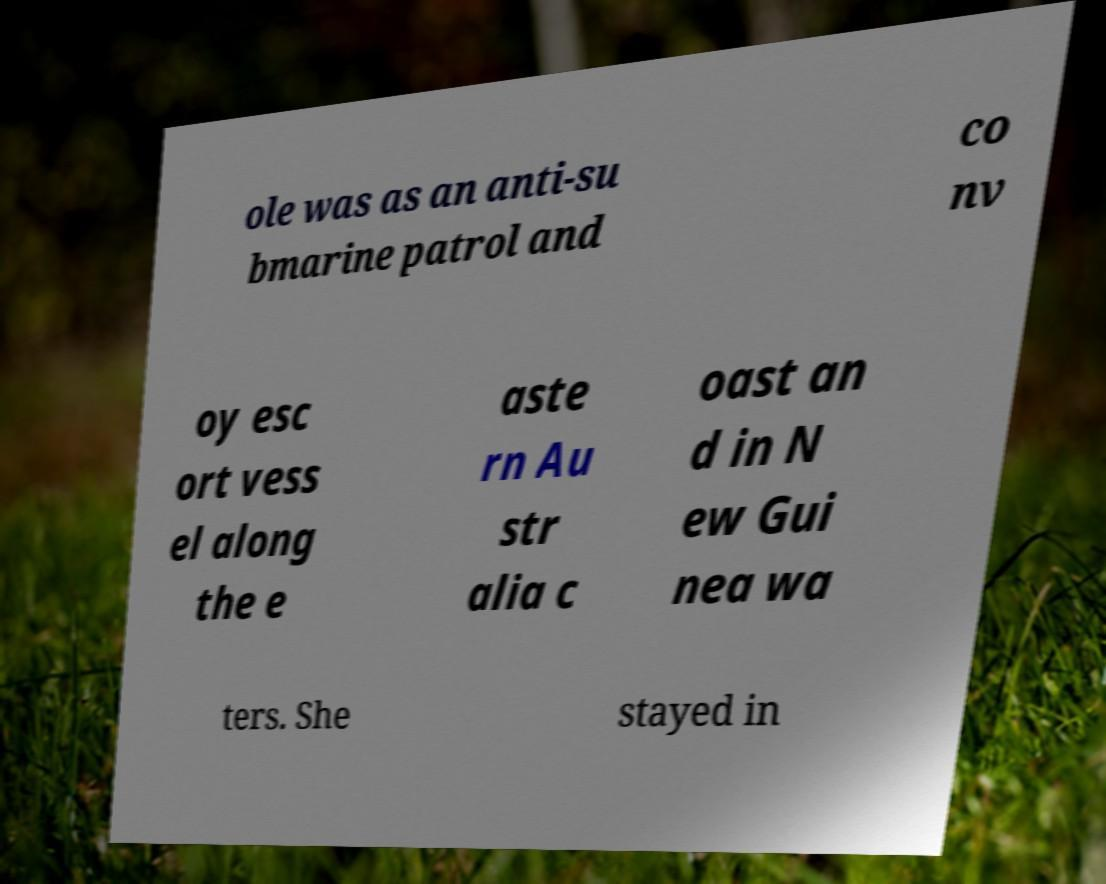Can you read and provide the text displayed in the image?This photo seems to have some interesting text. Can you extract and type it out for me? ole was as an anti-su bmarine patrol and co nv oy esc ort vess el along the e aste rn Au str alia c oast an d in N ew Gui nea wa ters. She stayed in 